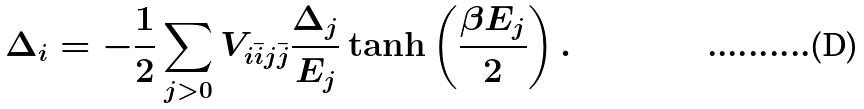Convert formula to latex. <formula><loc_0><loc_0><loc_500><loc_500>\Delta _ { i } = - \frac { 1 } { 2 } \sum _ { j > 0 } V _ { i \bar { i } j \bar { j } } \frac { \Delta _ { j } } { E _ { j } } \tanh \left ( \frac { \beta E _ { j } } { 2 } \right ) .</formula> 